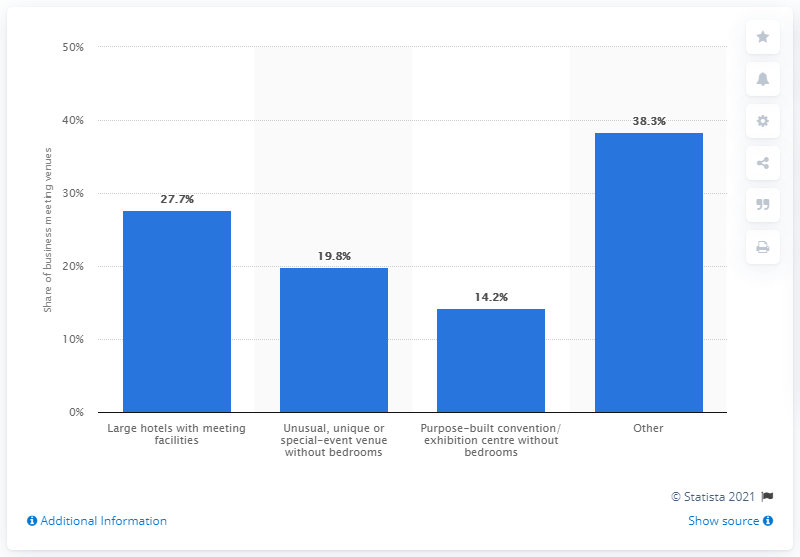Highlight a few significant elements in this photo. In 2011, the share of meeting venues in the UK was 27.7 percent. 